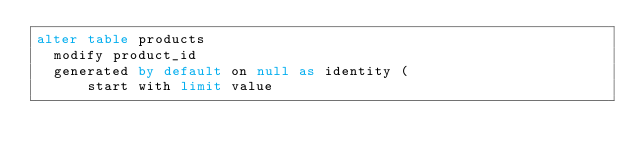Convert code to text. <code><loc_0><loc_0><loc_500><loc_500><_SQL_>alter table products 
  modify product_id 
  generated by default on null as identity (
      start with limit value </code> 